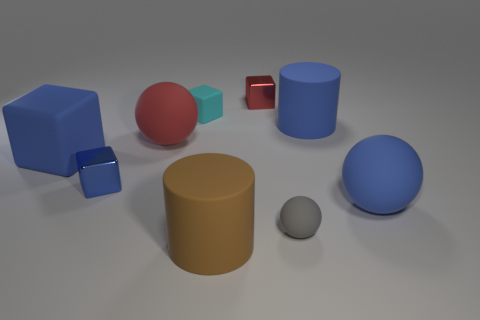Add 1 cyan cubes. How many objects exist? 10 Subtract all spheres. How many objects are left? 6 Add 2 cyan metallic cylinders. How many cyan metallic cylinders exist? 2 Subtract 0 purple cylinders. How many objects are left? 9 Subtract all gray balls. Subtract all small brown cubes. How many objects are left? 8 Add 6 small red shiny blocks. How many small red shiny blocks are left? 7 